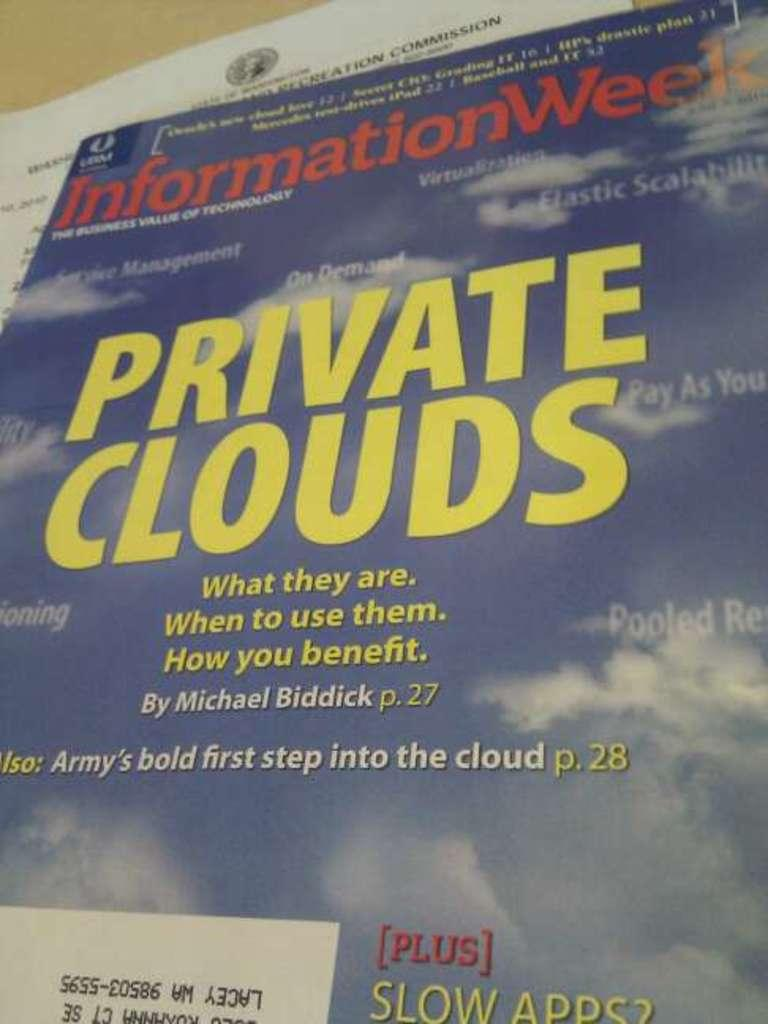What is present on the table in the image? There is a book and paper placed on a table in the image. What type of object is the book? The book is a physical object that can be read and contains information or stories. How is the paper positioned in relation to the book? The paper is placed on the table alongside the book. What type of quartz is visible on the table in the image? There is no quartz present in the image; it only features a book and paper on a table. 